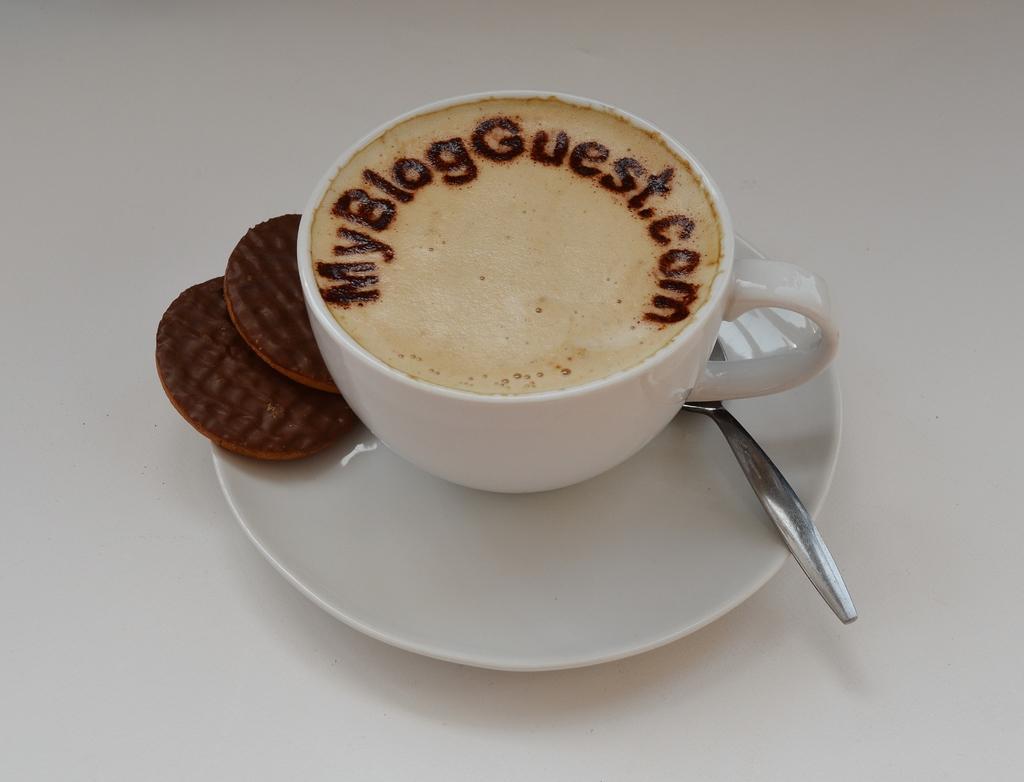Could you give a brief overview of what you see in this image? In the picture I can see a cup, biscuits, spoon on white color saucer. These objects are on a white color surface. 